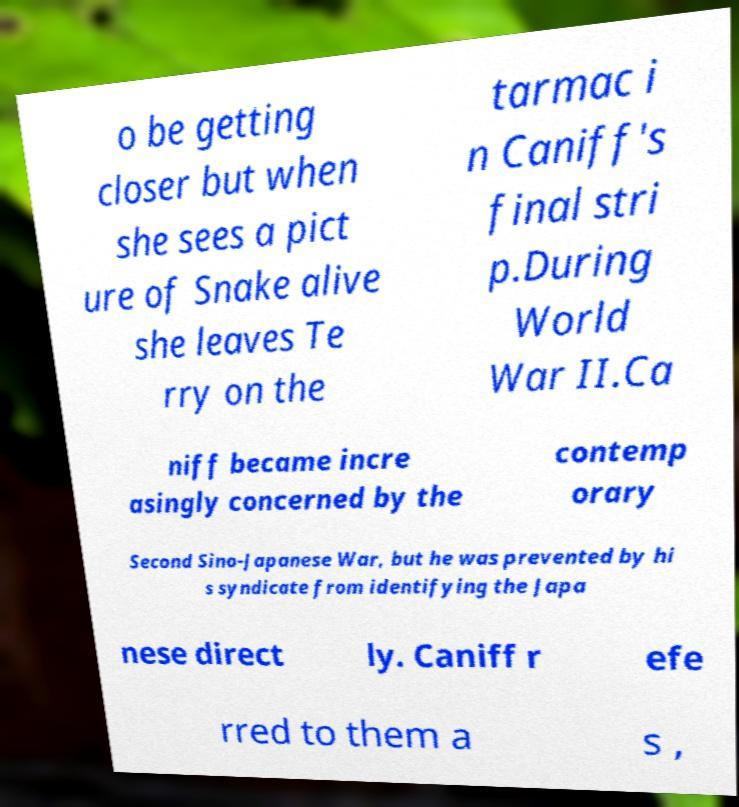Could you extract and type out the text from this image? o be getting closer but when she sees a pict ure of Snake alive she leaves Te rry on the tarmac i n Caniff's final stri p.During World War II.Ca niff became incre asingly concerned by the contemp orary Second Sino-Japanese War, but he was prevented by hi s syndicate from identifying the Japa nese direct ly. Caniff r efe rred to them a s , 